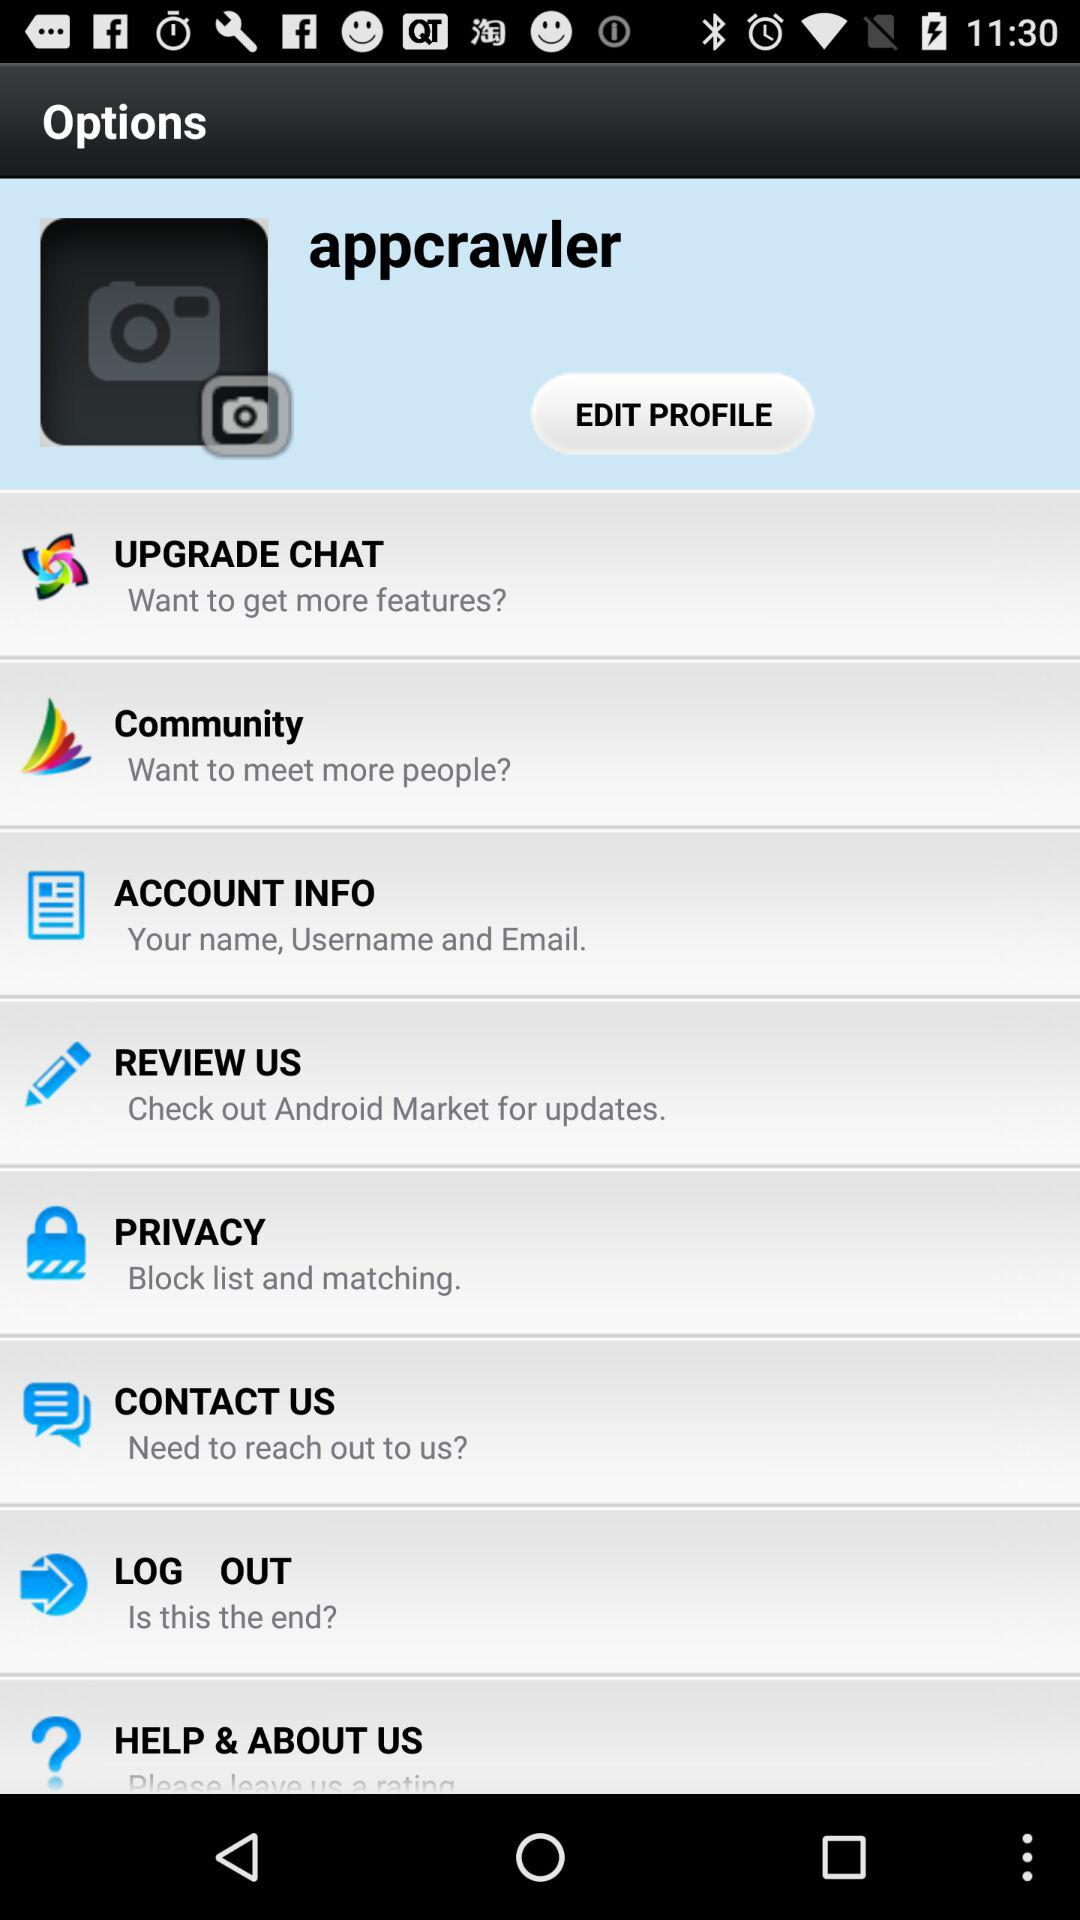Where can the user check for updates? The user can check for updates on "Android Market". 